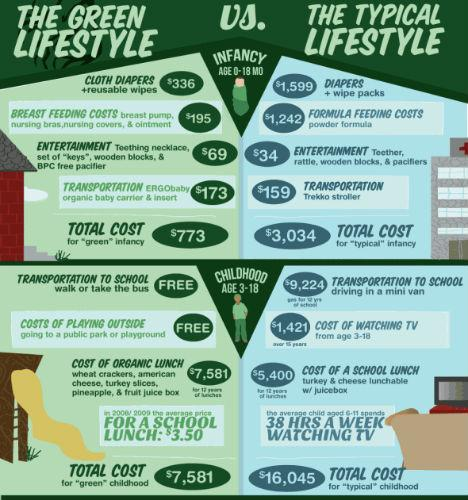Highlight a few significant elements in this photo. Feeding costs for infants in their typical age range are generally more expensive than those of infants in the green stage of development, with a difference of $1,047. The total cost difference between green infancy and typical infancy is $2,261. 